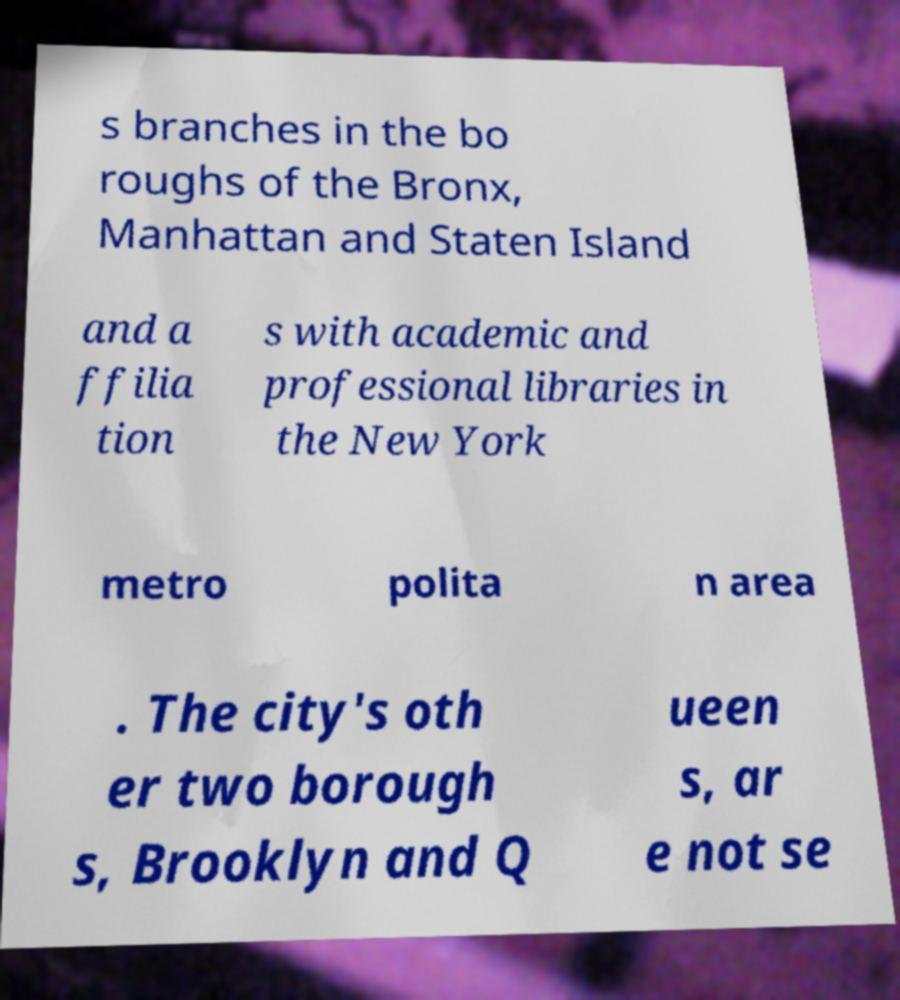I need the written content from this picture converted into text. Can you do that? s branches in the bo roughs of the Bronx, Manhattan and Staten Island and a ffilia tion s with academic and professional libraries in the New York metro polita n area . The city's oth er two borough s, Brooklyn and Q ueen s, ar e not se 